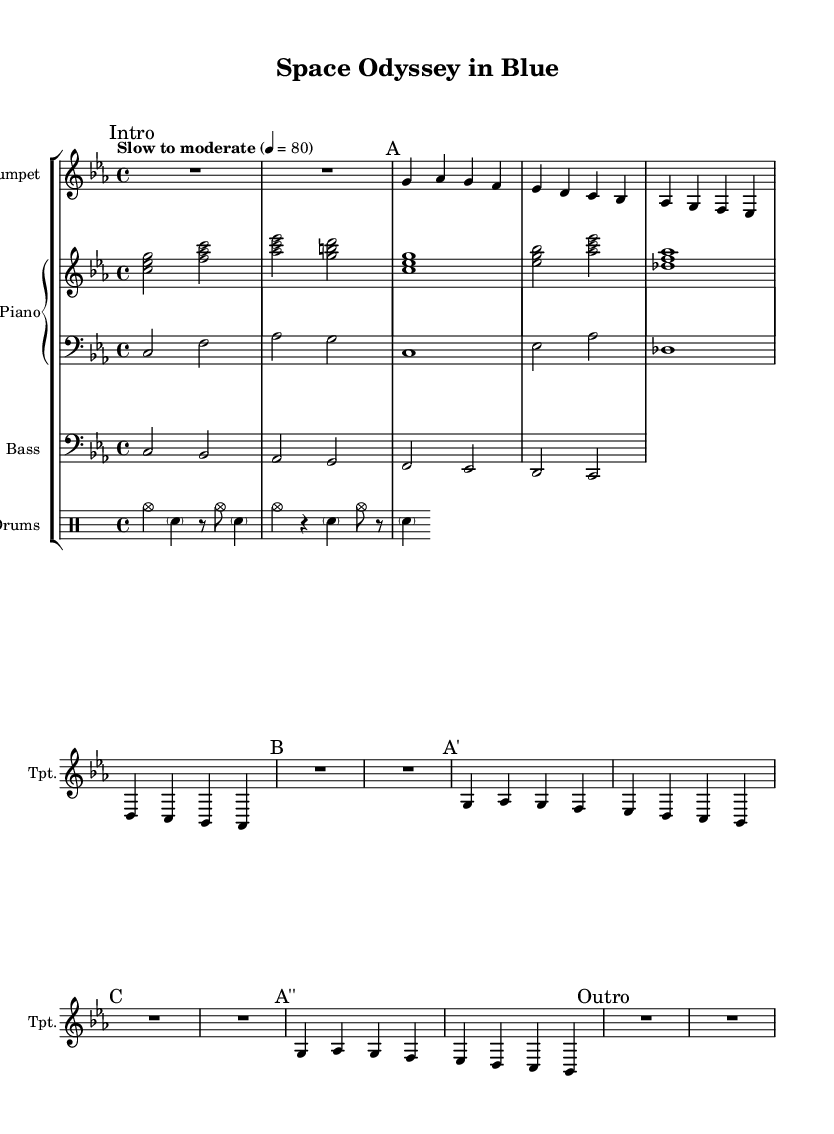What key is this music written in? The key signature is indicated at the beginning with a C minor signature, which has three flats (B flat, E flat, and A flat).
Answer: C minor What is the time signature of this piece? The time signature is shown at the beginning of the score, noted as 4/4, meaning there are four beats in a measure.
Answer: 4/4 What is the tempo marking for this piece? The tempo is explicitly stated in the beginning as "Slow to moderate" with a metronome marking of 4 = 80, which indicates the speed of the music.
Answer: Slow to moderate How many measures are there in section A? Section A is represented in the music and consists of four measures leading up to section B, which can be counted directly from the notation.
Answer: 4 What is the main rhythmic element used in the drums part? In the drums part, the primary rhythm consists of a combination of cymbals and snare hits, showcased through rests and notes arranged over the measures.
Answer: Cymbals and snare What makes this piece representative of cool jazz? Cool jazz is characterized by a smooth and relaxed style, which is evident in the melodic phrasing, the use of soft dynamics, and a laid-back tempo throughout the piece.
Answer: Smooth and relaxed style 